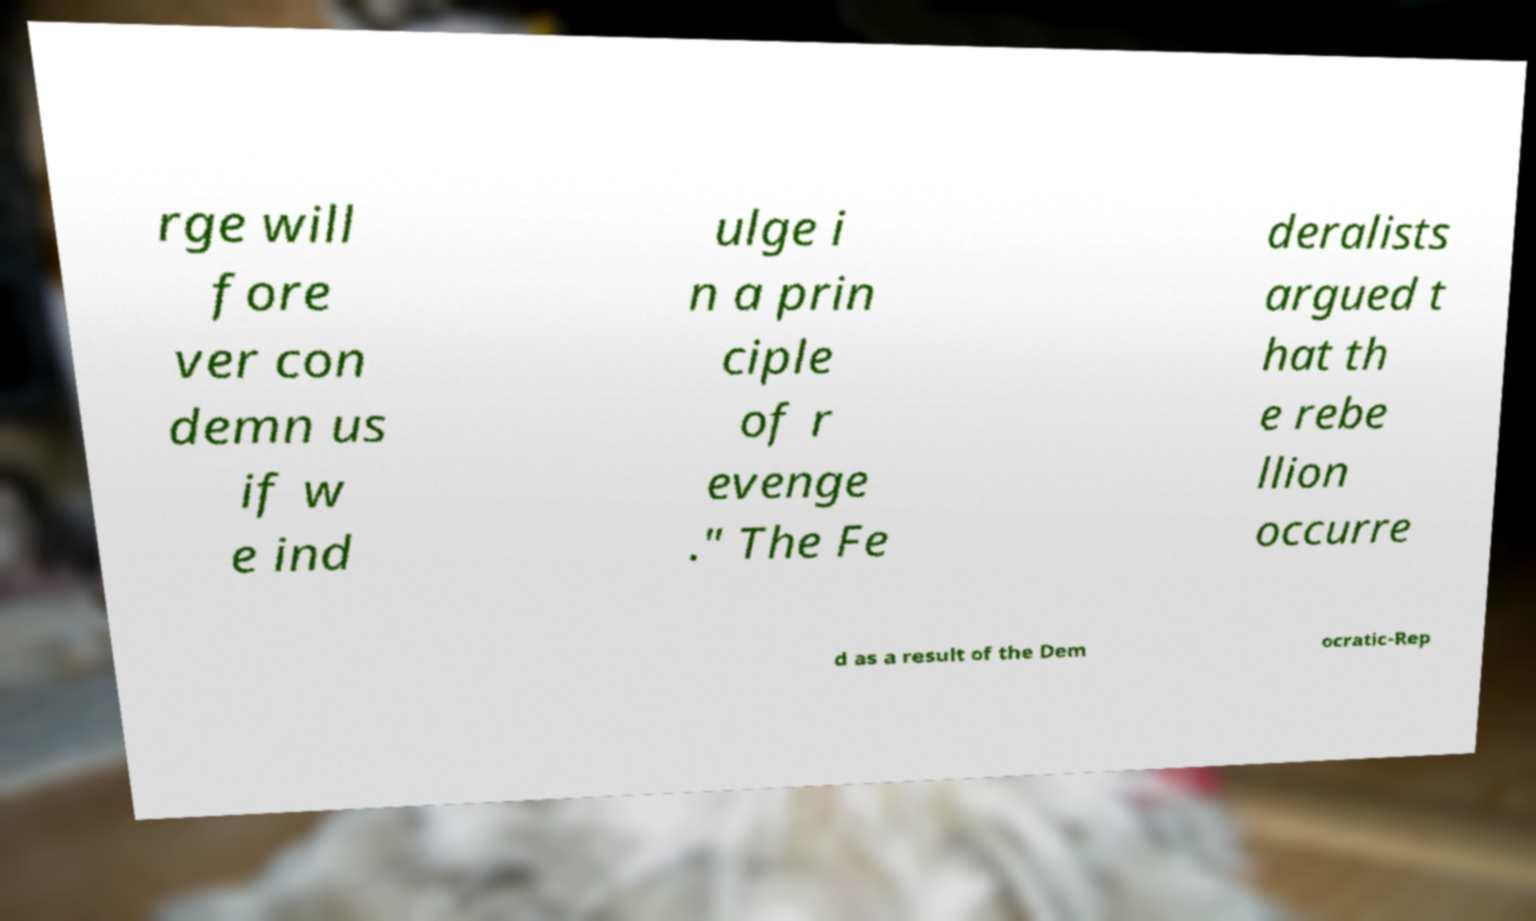Could you assist in decoding the text presented in this image and type it out clearly? rge will fore ver con demn us if w e ind ulge i n a prin ciple of r evenge ." The Fe deralists argued t hat th e rebe llion occurre d as a result of the Dem ocratic-Rep 